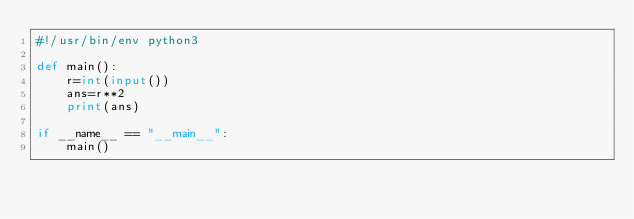<code> <loc_0><loc_0><loc_500><loc_500><_Python_>#!/usr/bin/env python3

def main():
    r=int(input())
    ans=r**2
    print(ans)
    
if __name__ == "__main__":
    main()
</code> 